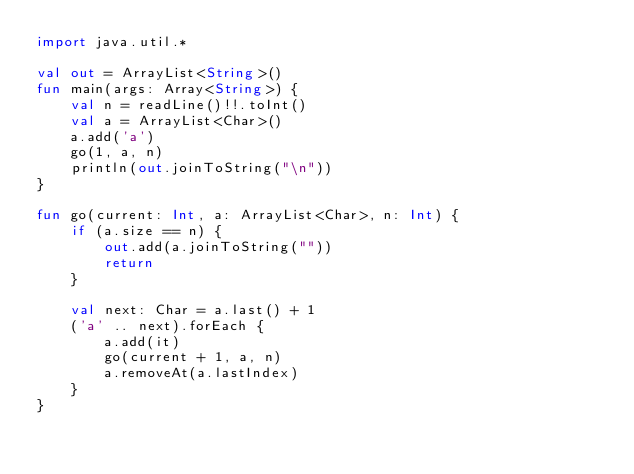<code> <loc_0><loc_0><loc_500><loc_500><_Kotlin_>import java.util.*

val out = ArrayList<String>()
fun main(args: Array<String>) {
    val n = readLine()!!.toInt()
    val a = ArrayList<Char>()
    a.add('a')
    go(1, a, n)
    println(out.joinToString("\n"))
}

fun go(current: Int, a: ArrayList<Char>, n: Int) {
    if (a.size == n) {
        out.add(a.joinToString(""))
        return
    }

    val next: Char = a.last() + 1
    ('a' .. next).forEach {
        a.add(it)
        go(current + 1, a, n)
        a.removeAt(a.lastIndex)
    }
}</code> 